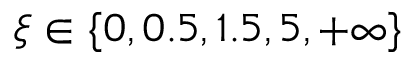<formula> <loc_0><loc_0><loc_500><loc_500>\xi \in \{ 0 , 0 . 5 , 1 . 5 , 5 , + \infty \}</formula> 